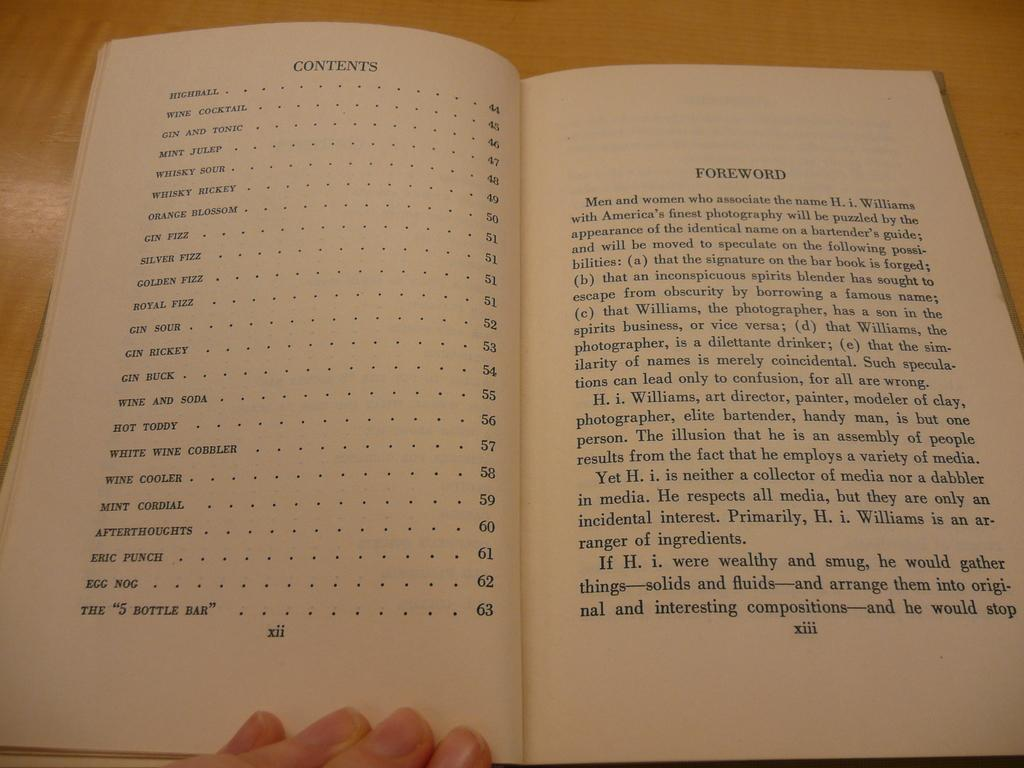<image>
Render a clear and concise summary of the photo. A person holding open a book to the Contents page. 